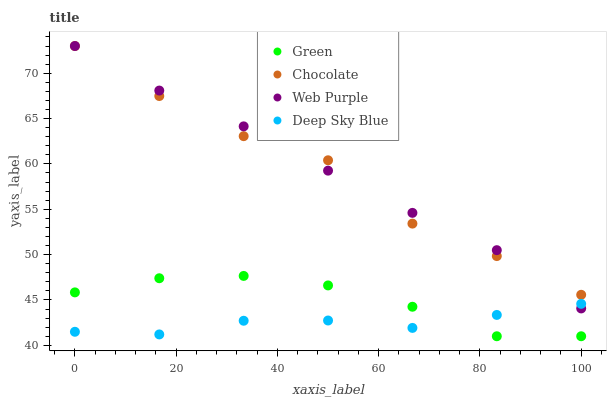Does Deep Sky Blue have the minimum area under the curve?
Answer yes or no. Yes. Does Web Purple have the maximum area under the curve?
Answer yes or no. Yes. Does Green have the minimum area under the curve?
Answer yes or no. No. Does Green have the maximum area under the curve?
Answer yes or no. No. Is Web Purple the smoothest?
Answer yes or no. Yes. Is Chocolate the roughest?
Answer yes or no. Yes. Is Green the smoothest?
Answer yes or no. No. Is Green the roughest?
Answer yes or no. No. Does Green have the lowest value?
Answer yes or no. Yes. Does Deep Sky Blue have the lowest value?
Answer yes or no. No. Does Chocolate have the highest value?
Answer yes or no. Yes. Does Green have the highest value?
Answer yes or no. No. Is Green less than Web Purple?
Answer yes or no. Yes. Is Chocolate greater than Green?
Answer yes or no. Yes. Does Deep Sky Blue intersect Green?
Answer yes or no. Yes. Is Deep Sky Blue less than Green?
Answer yes or no. No. Is Deep Sky Blue greater than Green?
Answer yes or no. No. Does Green intersect Web Purple?
Answer yes or no. No. 